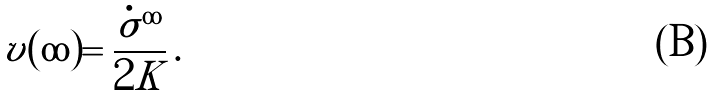Convert formula to latex. <formula><loc_0><loc_0><loc_500><loc_500>\tilde { v } ( \infty ) = \frac { \dot { \sigma } ^ { \infty } } { 2 K } \, .</formula> 